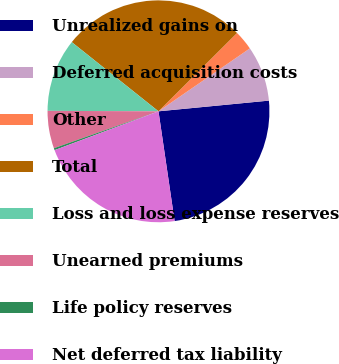<chart> <loc_0><loc_0><loc_500><loc_500><pie_chart><fcel>Unrealized gains on<fcel>Deferred acquisition costs<fcel>Other<fcel>Total<fcel>Loss and loss expense reserves<fcel>Unearned premiums<fcel>Life policy reserves<fcel>Net deferred tax liability<nl><fcel>24.22%<fcel>8.06%<fcel>2.88%<fcel>26.81%<fcel>10.65%<fcel>5.47%<fcel>0.29%<fcel>21.63%<nl></chart> 